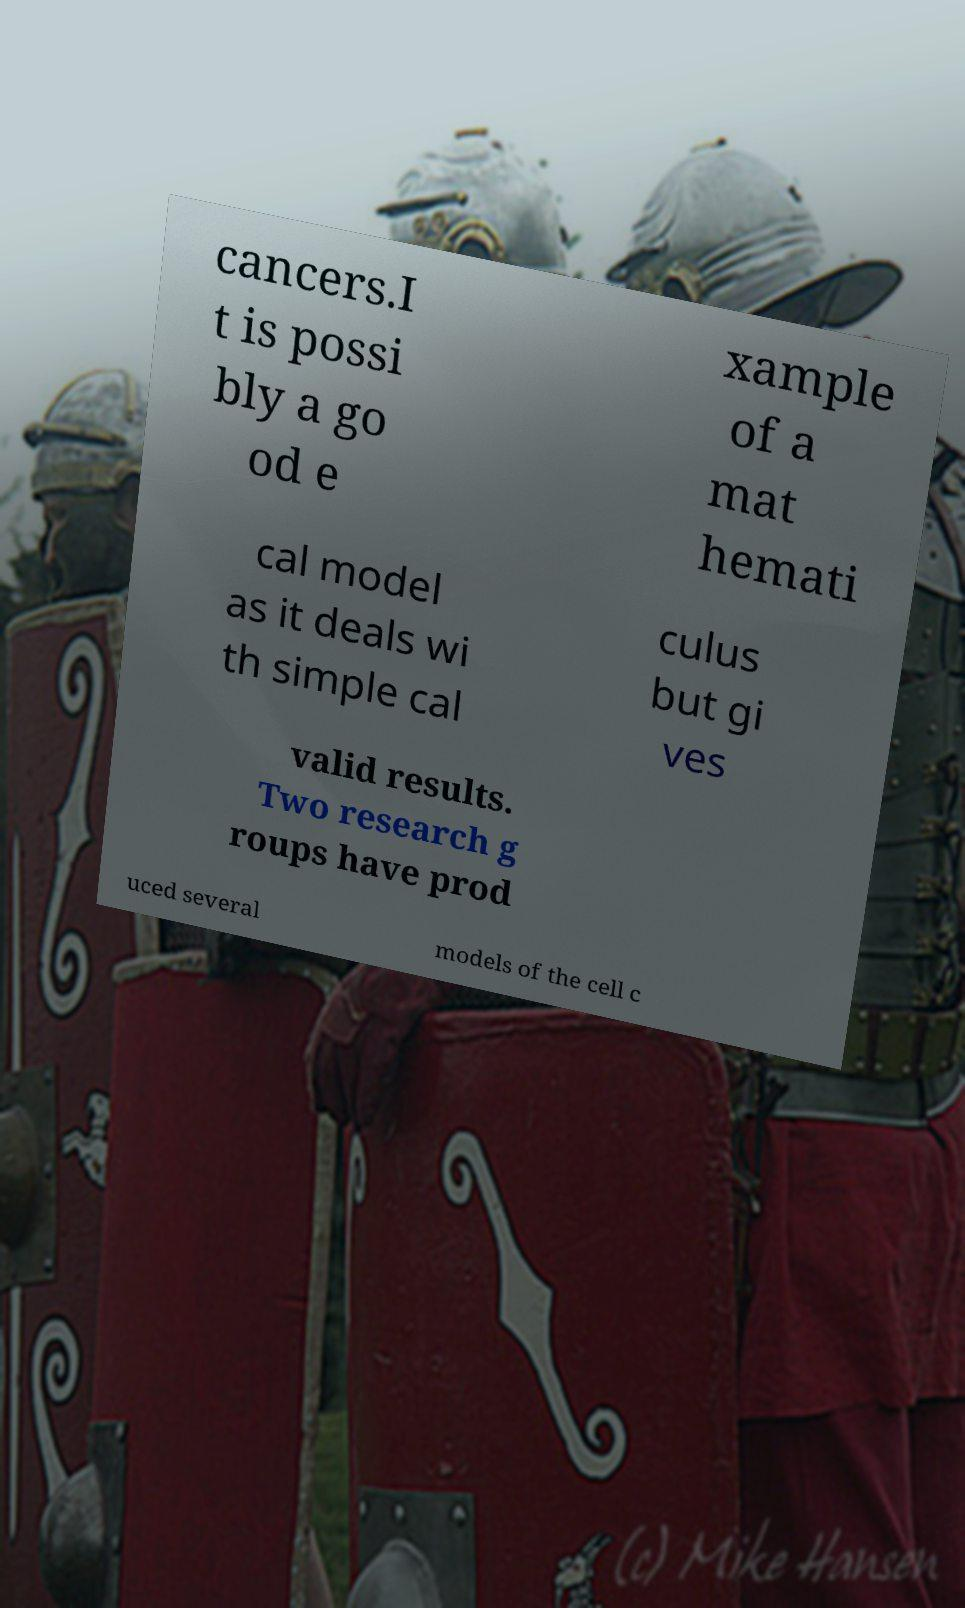Could you assist in decoding the text presented in this image and type it out clearly? cancers.I t is possi bly a go od e xample of a mat hemati cal model as it deals wi th simple cal culus but gi ves valid results. Two research g roups have prod uced several models of the cell c 